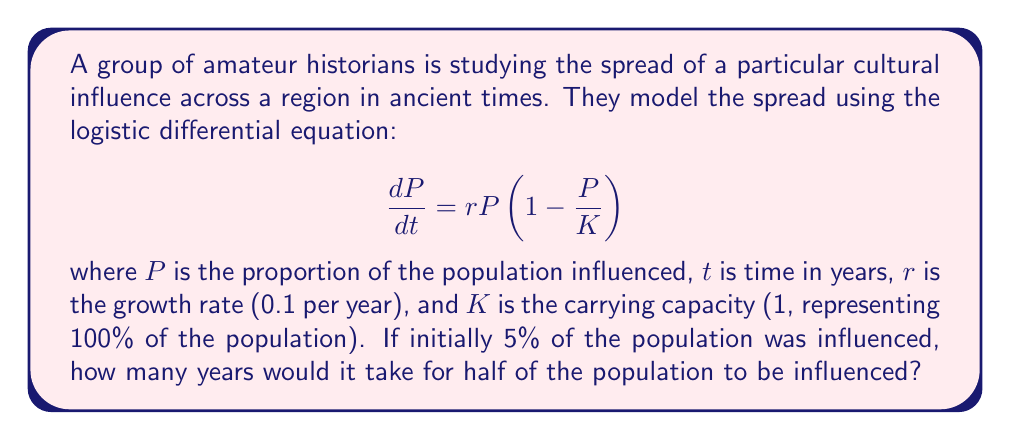Teach me how to tackle this problem. To solve this problem, we'll follow these steps:

1) The logistic equation has the following solution:

   $$P(t) = \frac{K}{1 + (\frac{K}{P_0} - 1)e^{-rt}}$$

   where $P_0$ is the initial proportion of the population influenced.

2) We're given:
   $K = 1$, $r = 0.1$, $P_0 = 0.05$, and we want to find $t$ when $P(t) = 0.5$

3) Substituting these values into the equation:

   $$0.5 = \frac{1}{1 + (\frac{1}{0.05} - 1)e^{-0.1t}}$$

4) Simplify:
   $$0.5 = \frac{1}{1 + 19e^{-0.1t}}$$

5) Multiply both sides by the denominator:
   $$0.5(1 + 19e^{-0.1t}) = 1$$

6) Distribute:
   $$0.5 + 9.5e^{-0.1t} = 1$$

7) Subtract 0.5 from both sides:
   $$9.5e^{-0.1t} = 0.5$$

8) Divide both sides by 9.5:
   $$e^{-0.1t} = \frac{1}{19}$$

9) Take the natural log of both sides:
   $$-0.1t = \ln(\frac{1}{19})$$

10) Divide both sides by -0.1:
    $$t = -10\ln(\frac{1}{19}) = 10\ln(19) \approx 29.07$$

Therefore, it would take approximately 29.07 years for half of the population to be influenced.
Answer: 29.07 years 